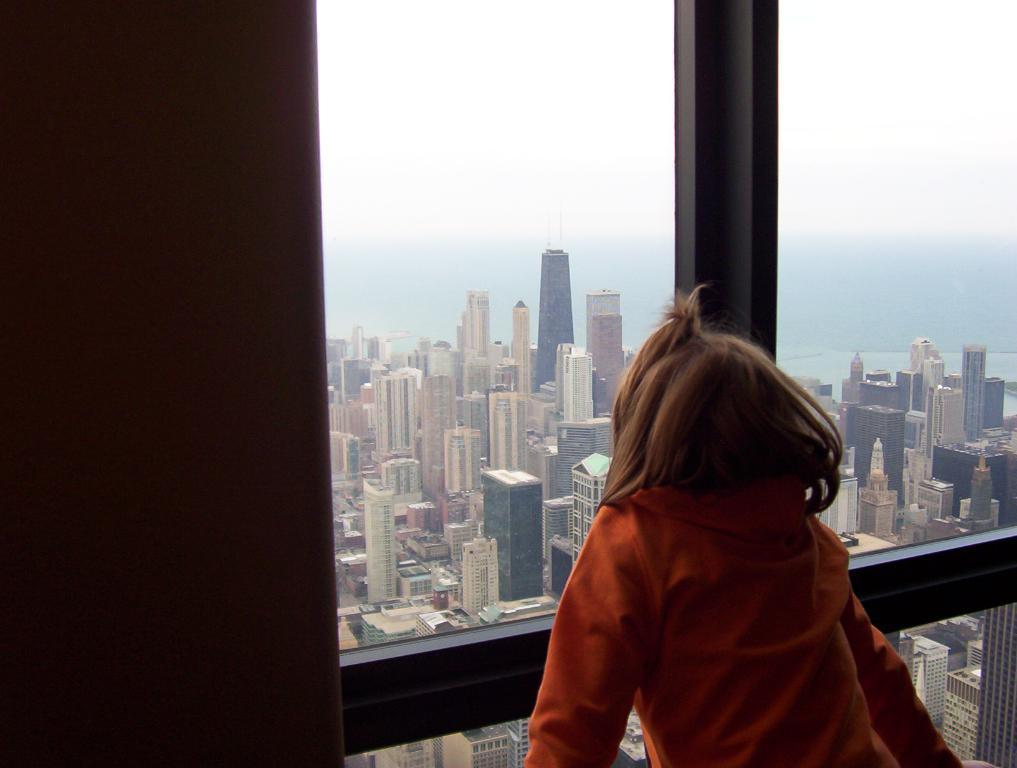Can you describe this image briefly? In this image I can see a person wearing an orange dress. Back Side I can see buildings and glass window. The sky is in blue and white color. 